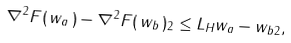<formula> <loc_0><loc_0><loc_500><loc_500>\| \nabla ^ { 2 } F ( \, w _ { a } \, ) - \nabla ^ { 2 } F ( \, w _ { b } \, ) \| _ { 2 } \leq L _ { H } \| w _ { a } - w _ { b } \| _ { 2 } ,</formula> 